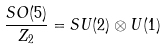Convert formula to latex. <formula><loc_0><loc_0><loc_500><loc_500>\frac { S O ( 5 ) } { Z _ { 2 } } = S U ( 2 ) \otimes U ( 1 )</formula> 